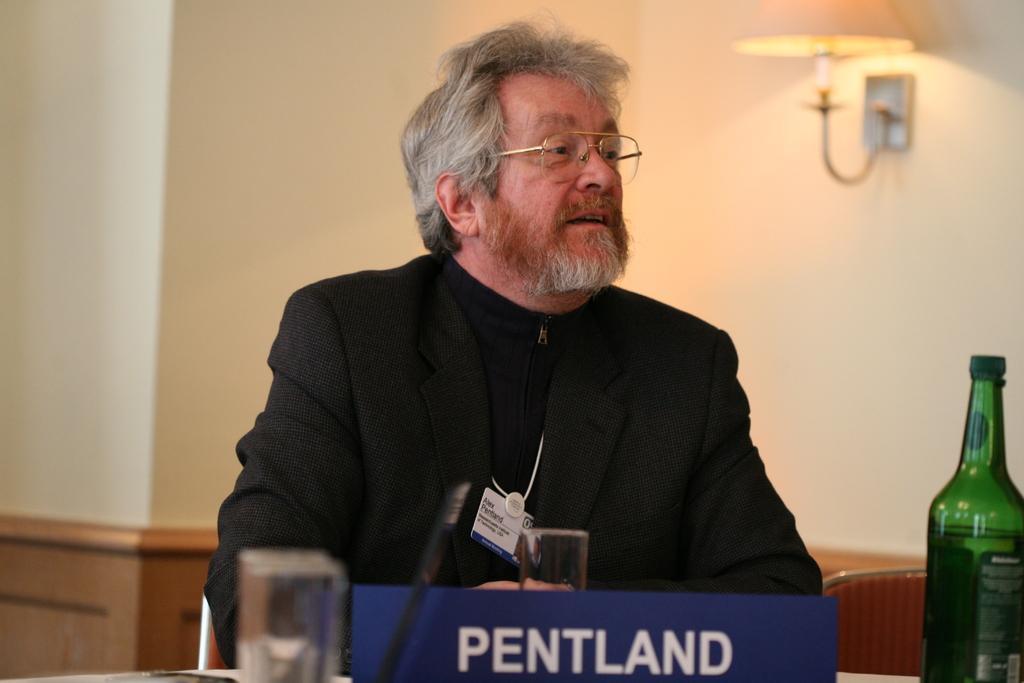Could you give a brief overview of what you see in this image? In this image we can see a old man wearing black blazer and spectacles on his face. We can see a blue board written Pentland on it. On the table we can see a bottle placed and a glass. In the background of the image we can see a lamp light placed on the wall. 